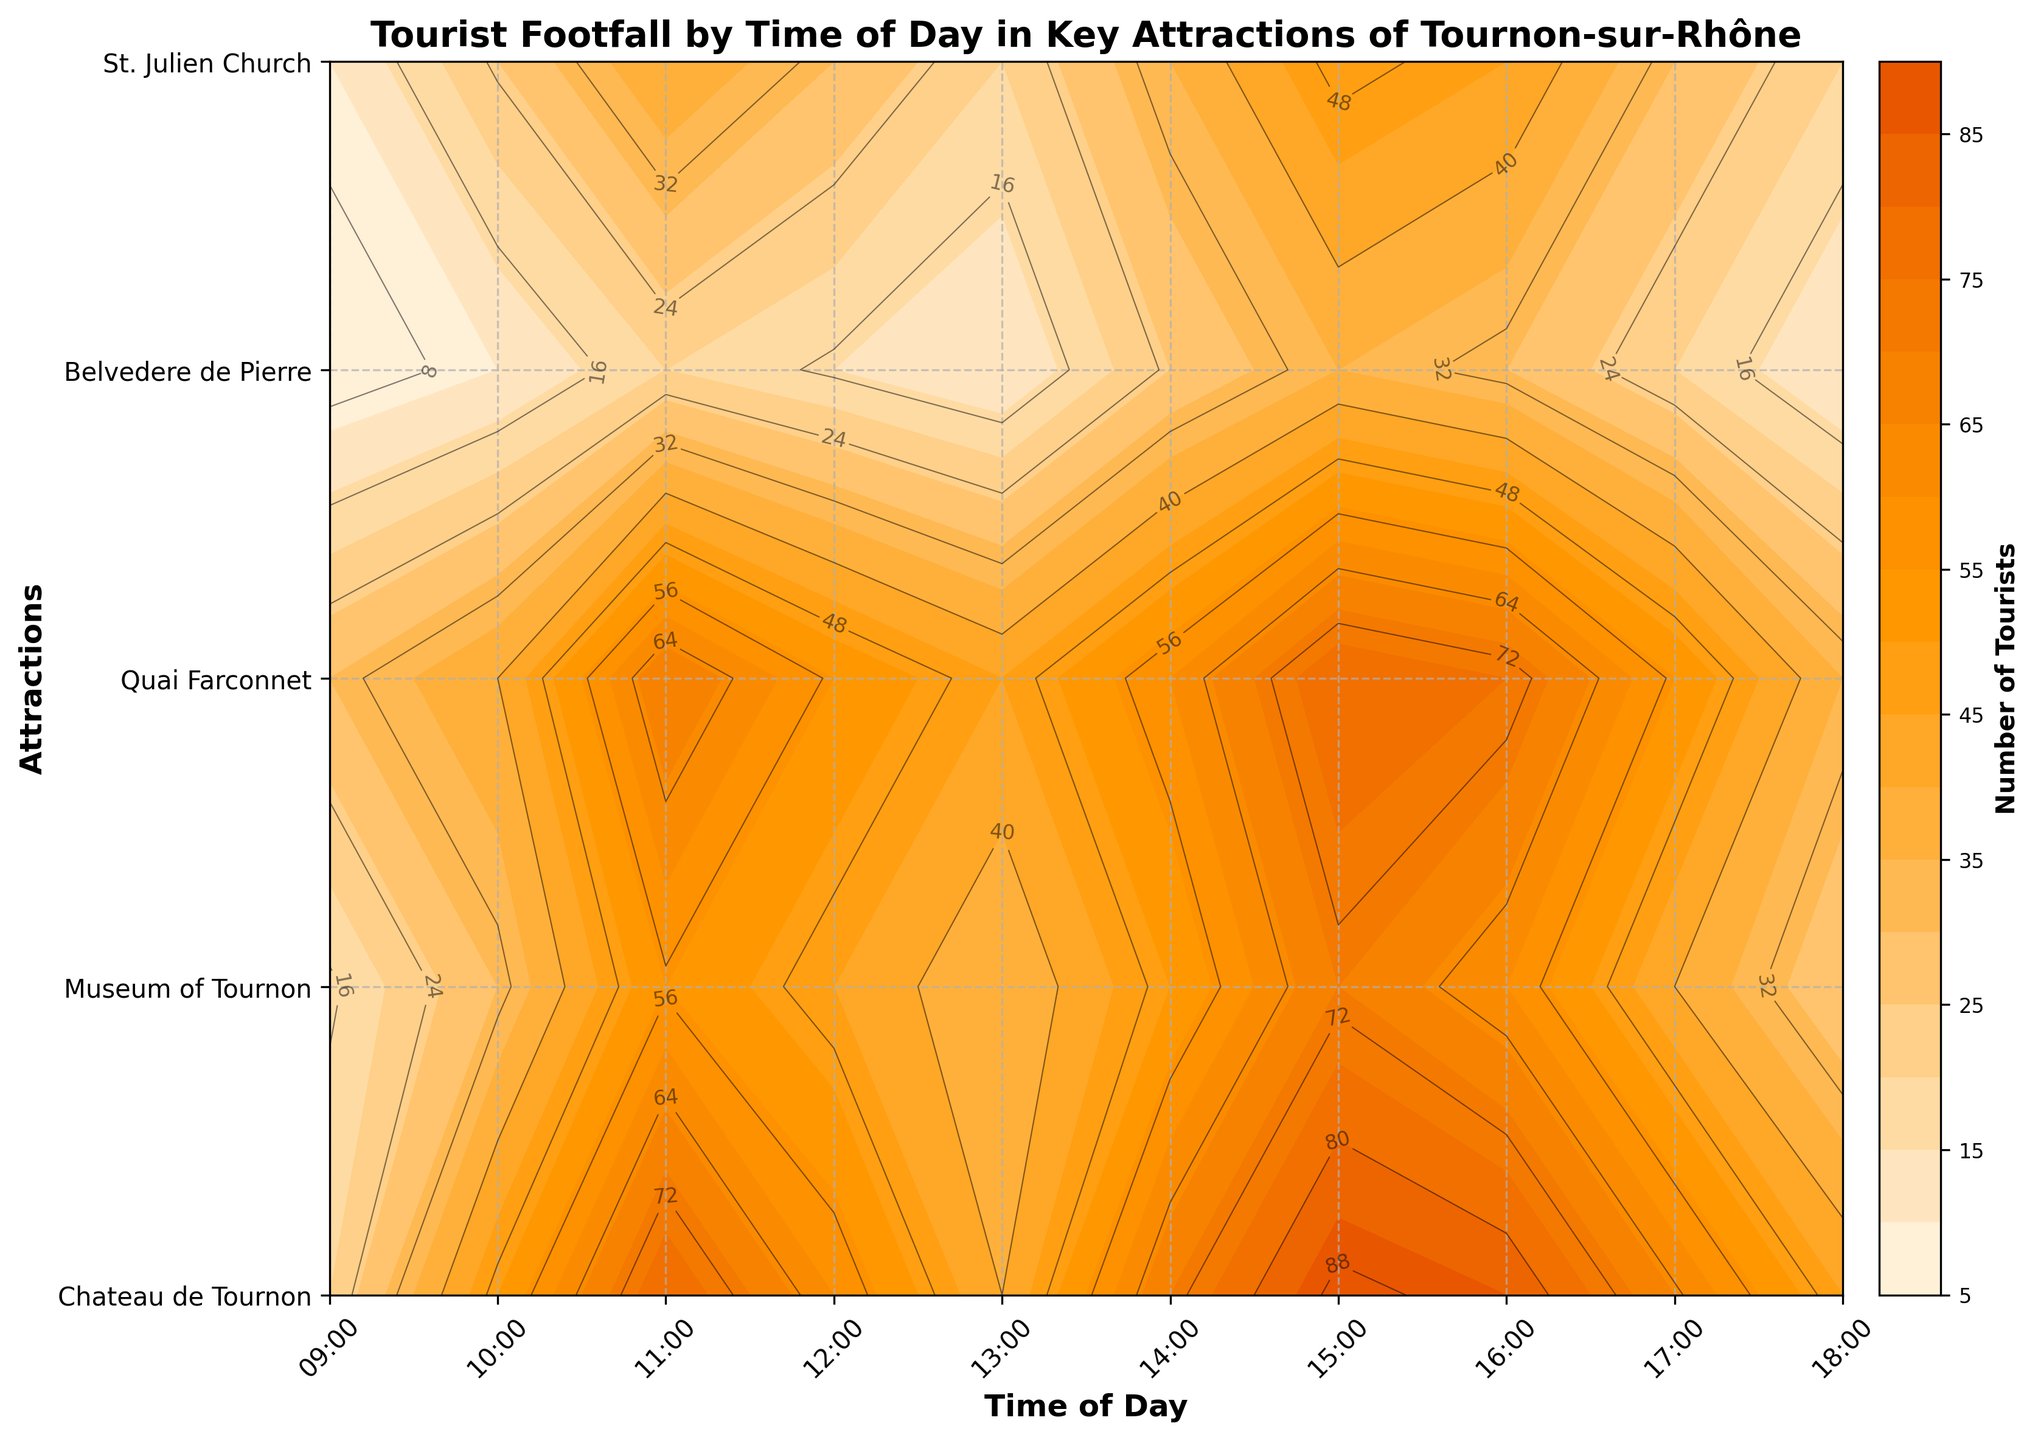What is the title of the figure? The title of the figure is typically located at the top of the plot and summarises the overall topic or focus of the data represented. In this figure, the title clearly indicates the main subject being portrayed.
Answer: Tourist Footfall by Time of Day in Key Attractions of Tournon-sur-Rhône What are the labels on the X-axis and Y-axis? The labels on the axes describe what each axis represents. For this plot, the X-axis label describes time, and the Y-axis label describes the attractions being explored.
Answer: Time of Day, Attractions At what time of day did ‘Chateau de Tournon’ experience the highest tourist footfall? To find this, locate the row corresponding to 'Chateau de Tournon' and identify the highest contour value within that row. This typically involves looking for the darkest color or highest numerical value on the contour lines.
Answer: 15:00 Which attraction has the lowest footfall at 11:00? To identify this, check the contour lines at the 11:00 mark and compare the values across all attractions. This involves finding the smallest value among all the lines at this specific time.
Answer: Belvedere de Pierre How does the footfall at 'St. Julien Church' at 17:00 compare to the footfall at 9:00? Compare the contour values for 'St. Julien Church' at both 17:00 and 9:00. By analyzing the lines or color shading intensity, we can determine which is higher or lower.
Answer: Higher at 17:00 What is the average tourist footfall at 'Quai Farconnet' between 9:00 and 18:00? To find the average footfall, sum all the contour values for 'Quai Farconnet' from 9:00 to 18:00 and then divide by the number of time points (which is 10). Add values: 30 + 40 + 70 + 55 + 45 + 60 + 80 + 75 + 55 + 35 = 545. Divide by 10: 545 / 10 = 54.5
Answer: 54.5 Between which hours is the tourist footfall at 'Museum of Tournon' the most stable? Stability implies the least fluctuation in the contour values. Identify the time range where the values change minimally by observing the contour levels closely within the rows for 'Museum of Tournon'.
Answer: Between 12:00 and 13:00 What is the overall trend in tourist footfall for 'Chateau de Tournon' throughout the day? By observing how the contour values vary from 9:00 to 18:00 for 'Chateau de Tournon', we notice if they are increasing, decreasing, or fluctuating, showing an overall trend.
Answer: Increasing with a peak at 15:00 then decreasing At which attraction and time is the highest overall footfall noted? Check across all contour plots to find the darkest color or highest value line, indicating the highest footfall across attractions and times.
Answer: Chateau de Tournon at 15:00 